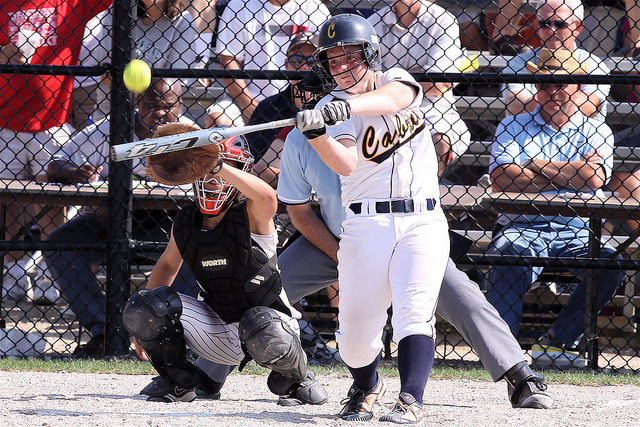Describe a possible scenario leading to a win for the Cavaliers in this game. The game is in its final inning, and the Cavaliers are trailing by one run. The batter in the image steps up to the plate with two outs and a runner on second base. She swings her bat with determination and, with a crack, sends the ball flying deep into the outfield. The runner on second races home, and the batter sprints around the bases, making it to third base safely. The crowd erupts in cheers. On the next pitch, the batter steals home, securing a thrilling victory for the Cavaliers and earning her team a place in the championship game. 